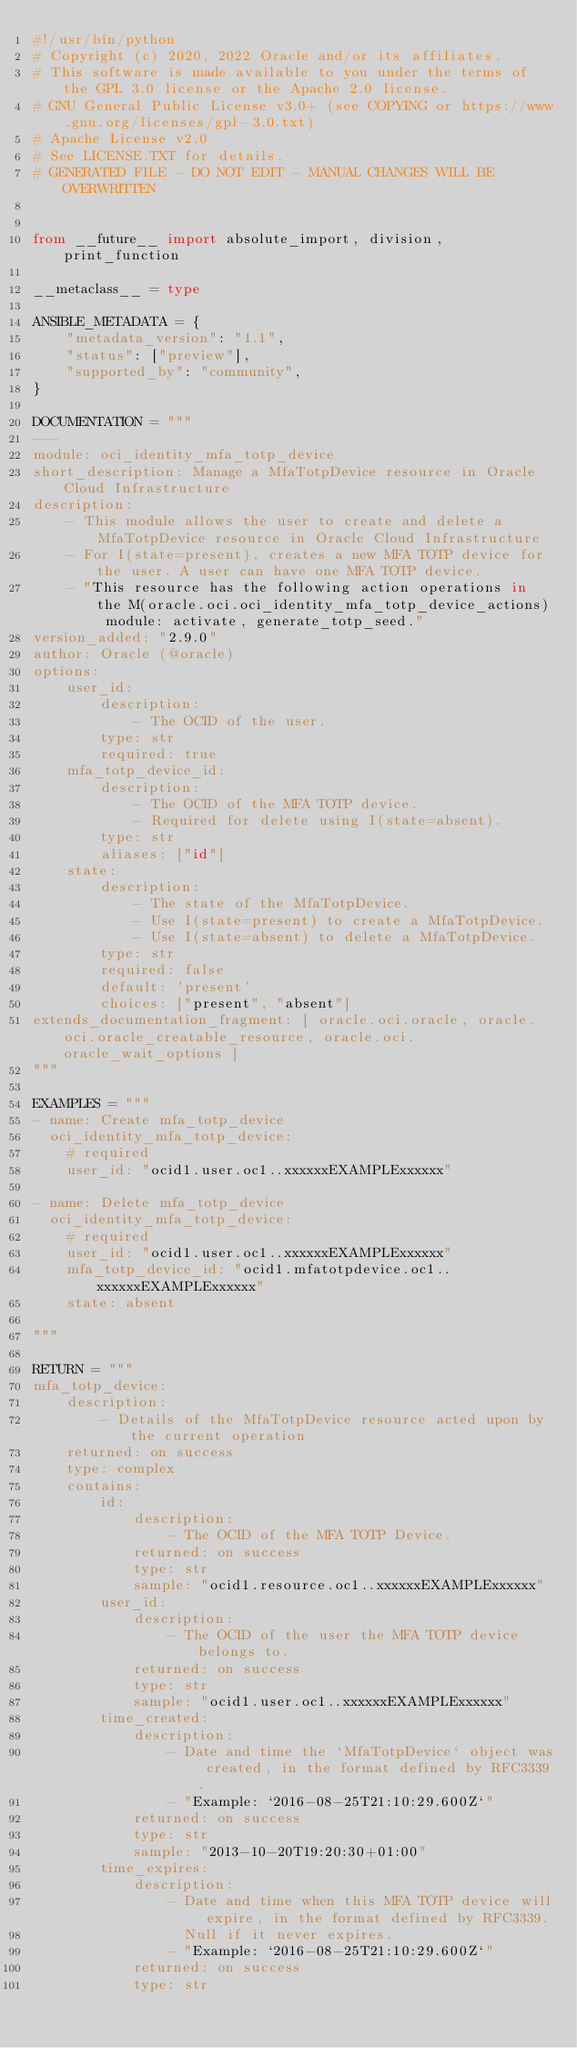Convert code to text. <code><loc_0><loc_0><loc_500><loc_500><_Python_>#!/usr/bin/python
# Copyright (c) 2020, 2022 Oracle and/or its affiliates.
# This software is made available to you under the terms of the GPL 3.0 license or the Apache 2.0 license.
# GNU General Public License v3.0+ (see COPYING or https://www.gnu.org/licenses/gpl-3.0.txt)
# Apache License v2.0
# See LICENSE.TXT for details.
# GENERATED FILE - DO NOT EDIT - MANUAL CHANGES WILL BE OVERWRITTEN


from __future__ import absolute_import, division, print_function

__metaclass__ = type

ANSIBLE_METADATA = {
    "metadata_version": "1.1",
    "status": ["preview"],
    "supported_by": "community",
}

DOCUMENTATION = """
---
module: oci_identity_mfa_totp_device
short_description: Manage a MfaTotpDevice resource in Oracle Cloud Infrastructure
description:
    - This module allows the user to create and delete a MfaTotpDevice resource in Oracle Cloud Infrastructure
    - For I(state=present), creates a new MFA TOTP device for the user. A user can have one MFA TOTP device.
    - "This resource has the following action operations in the M(oracle.oci.oci_identity_mfa_totp_device_actions) module: activate, generate_totp_seed."
version_added: "2.9.0"
author: Oracle (@oracle)
options:
    user_id:
        description:
            - The OCID of the user.
        type: str
        required: true
    mfa_totp_device_id:
        description:
            - The OCID of the MFA TOTP device.
            - Required for delete using I(state=absent).
        type: str
        aliases: ["id"]
    state:
        description:
            - The state of the MfaTotpDevice.
            - Use I(state=present) to create a MfaTotpDevice.
            - Use I(state=absent) to delete a MfaTotpDevice.
        type: str
        required: false
        default: 'present'
        choices: ["present", "absent"]
extends_documentation_fragment: [ oracle.oci.oracle, oracle.oci.oracle_creatable_resource, oracle.oci.oracle_wait_options ]
"""

EXAMPLES = """
- name: Create mfa_totp_device
  oci_identity_mfa_totp_device:
    # required
    user_id: "ocid1.user.oc1..xxxxxxEXAMPLExxxxxx"

- name: Delete mfa_totp_device
  oci_identity_mfa_totp_device:
    # required
    user_id: "ocid1.user.oc1..xxxxxxEXAMPLExxxxxx"
    mfa_totp_device_id: "ocid1.mfatotpdevice.oc1..xxxxxxEXAMPLExxxxxx"
    state: absent

"""

RETURN = """
mfa_totp_device:
    description:
        - Details of the MfaTotpDevice resource acted upon by the current operation
    returned: on success
    type: complex
    contains:
        id:
            description:
                - The OCID of the MFA TOTP Device.
            returned: on success
            type: str
            sample: "ocid1.resource.oc1..xxxxxxEXAMPLExxxxxx"
        user_id:
            description:
                - The OCID of the user the MFA TOTP device belongs to.
            returned: on success
            type: str
            sample: "ocid1.user.oc1..xxxxxxEXAMPLExxxxxx"
        time_created:
            description:
                - Date and time the `MfaTotpDevice` object was created, in the format defined by RFC3339.
                - "Example: `2016-08-25T21:10:29.600Z`"
            returned: on success
            type: str
            sample: "2013-10-20T19:20:30+01:00"
        time_expires:
            description:
                - Date and time when this MFA TOTP device will expire, in the format defined by RFC3339.
                  Null if it never expires.
                - "Example: `2016-08-25T21:10:29.600Z`"
            returned: on success
            type: str</code> 